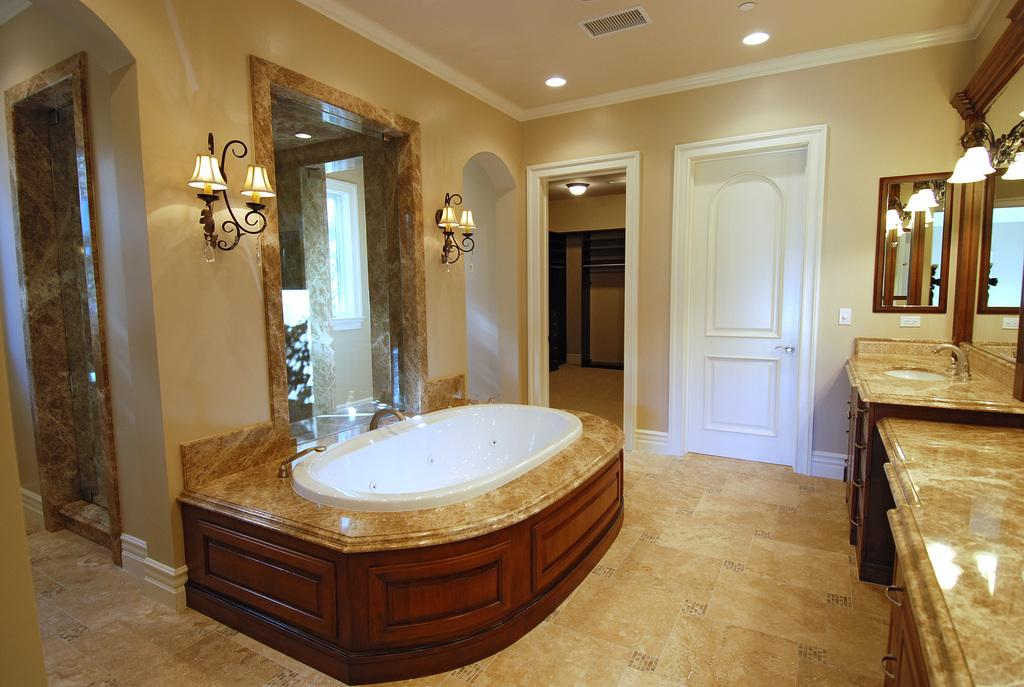What is the main fixture in the image? There is a bathtub in the image. What other plumbing fixture is present? There is a sink in the image. What is used to control the flow of water in the image? There is a tap in the image. What storage space is available in the image? There is a cupboard in the image. Where are the mirror and lights located in the image? The mirror and lights are attached to the wall. What is the color of the door in the image? The door in the image is white. What is the color of the wall in the image? The wall in the image is cream-colored. Can you hear the pigs squealing in the image? There are no pigs present in the image, so it is not possible to hear them squealing. 